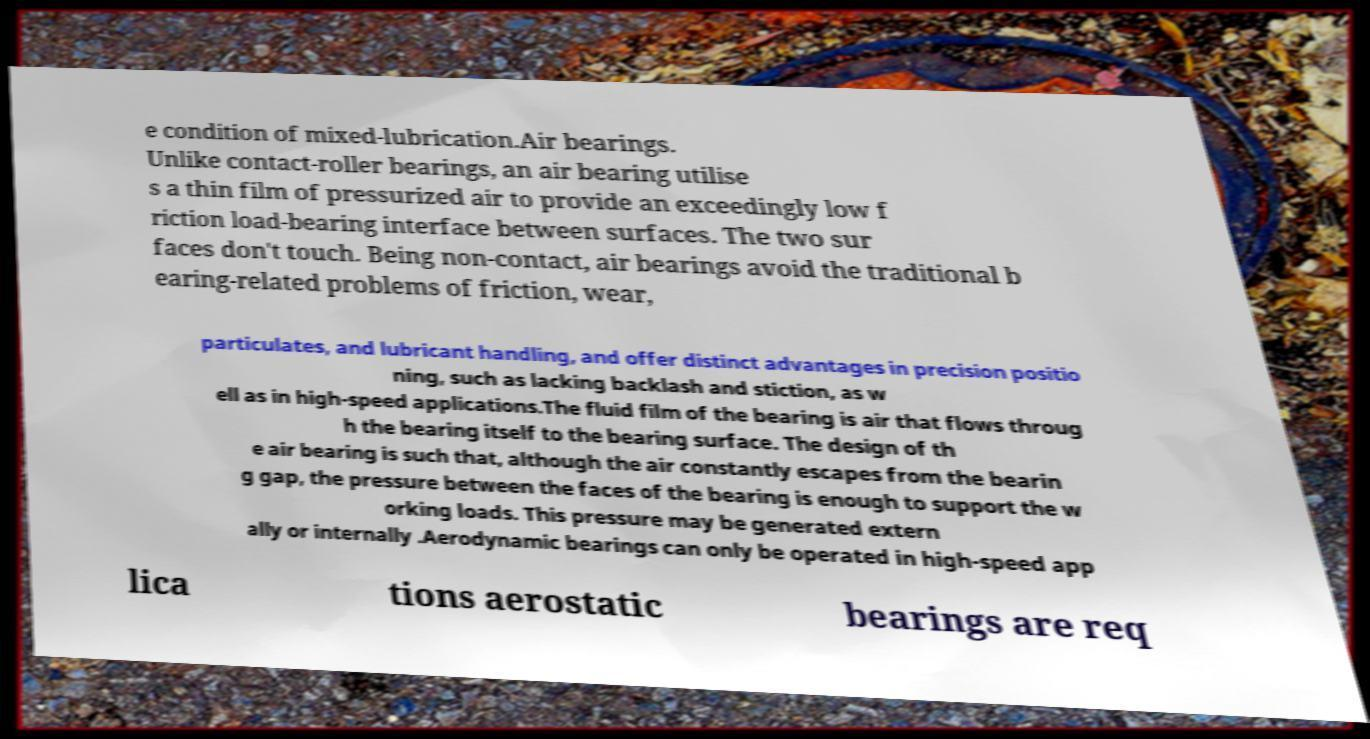There's text embedded in this image that I need extracted. Can you transcribe it verbatim? e condition of mixed-lubrication.Air bearings. Unlike contact-roller bearings, an air bearing utilise s a thin film of pressurized air to provide an exceedingly low f riction load-bearing interface between surfaces. The two sur faces don't touch. Being non-contact, air bearings avoid the traditional b earing-related problems of friction, wear, particulates, and lubricant handling, and offer distinct advantages in precision positio ning, such as lacking backlash and stiction, as w ell as in high-speed applications.The fluid film of the bearing is air that flows throug h the bearing itself to the bearing surface. The design of th e air bearing is such that, although the air constantly escapes from the bearin g gap, the pressure between the faces of the bearing is enough to support the w orking loads. This pressure may be generated extern ally or internally .Aerodynamic bearings can only be operated in high-speed app lica tions aerostatic bearings are req 